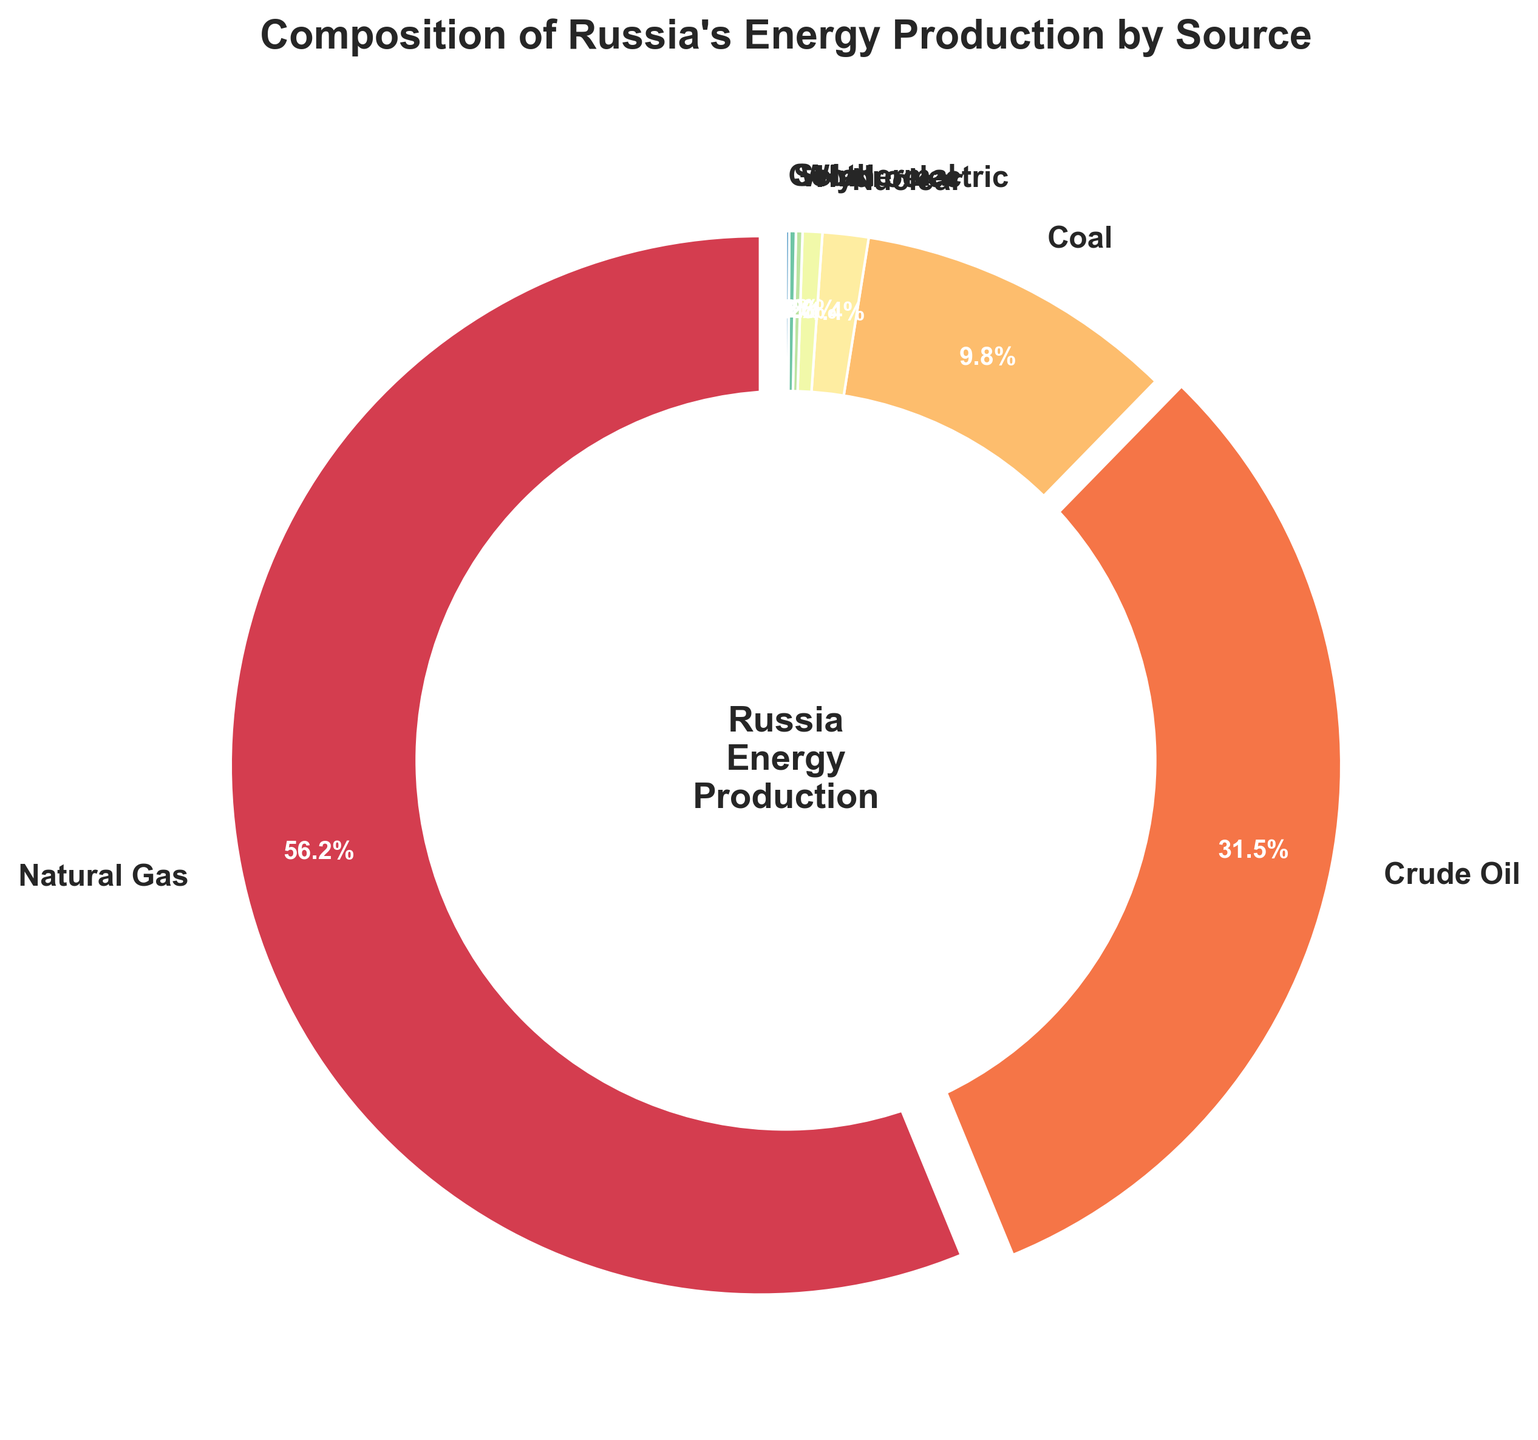What is the largest source of energy production in Russia? The figure shows energy sources with natural gas occupying the largest section.
Answer: Natural Gas Which energy source is responsible for more than half of the energy production in Russia? Natural gas is responsible for 56.2%, which is just over half of Russia's energy production.
Answer: Natural Gas What is the combined percentage of energy production from Nuclear, Hydroelectric, Wind, Solar, and Geothermal sources? Sum the percentages of Nuclear (1.4), Hydroelectric (0.6), Wind (0.2), Solar (0.2), and Geothermal (0.1): 1.4 + 0.6 + 0.2 + 0.2 + 0.1 = 2.5%
Answer: 2.5% How many sources contribute less than 10% each to Russia's energy production? Coal, Nuclear, Hydroelectric, Wind, Solar, and Geothermal all contribute less than 10%. This sums to 6 sources.
Answer: 6 Which is more significant in Russia's energy production, Coal or Crude Oil? By comparing the sectors, Crude Oil holds a larger portion at 31.5% than Coal at 9.8%.
Answer: Crude Oil By how much does the energy production from Natural Gas exceed that from Coal? Subtract the percentage of Coal (9.8) from Natural Gas (56.2), resulting in 56.2 - 9.8 = 46.4%
Answer: 46.4% What percentage of Russia's energy production comes from renewable sources (Hydroelectric, Wind, Solar, Geothermal)? Sum the percentages of renewable sources: Hydroelectric (0.6), Wind (0.2), Solar (0.2), Geothermal (0.1), resulting in 0.6 + 0.2 + 0.2 + 0.1 = 1.1%
Answer: 1.1% Which source has the smallest contribution to Russia's energy production? Geothermal occupies the smallest segment with 0.1%.
Answer: Geothermal What is the total percentage contribution of Natural Gas and Crude Oil combined? Sum the percentages of Natural Gas (56.2) and Crude Oil (31.5), which gives 56.2 + 31.5 = 87.7%
Answer: 87.7% Between Coal and Nuclear, which source contributes more to Russia's energy production and by how much? Compare Coal (9.8%) and Nuclear (1.4%) and subtract Nuclear from Coal: 9.8 - 1.4 = 8.4%.
Answer: Coal by 8.4% 